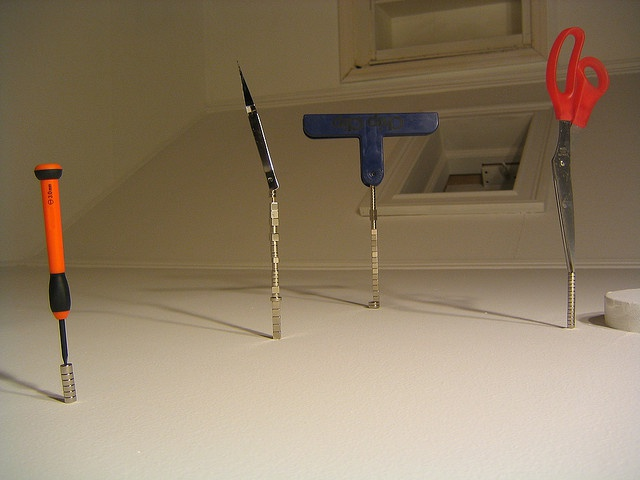Describe the objects in this image and their specific colors. I can see scissors in darkgreen, brown, gray, and black tones in this image. 